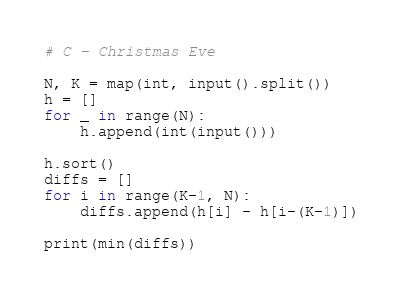<code> <loc_0><loc_0><loc_500><loc_500><_Python_># C - Christmas Eve

N, K = map(int, input().split())
h = []
for _ in range(N):
    h.append(int(input()))

h.sort()
diffs = []
for i in range(K-1, N):
    diffs.append(h[i] - h[i-(K-1)])

print(min(diffs))</code> 